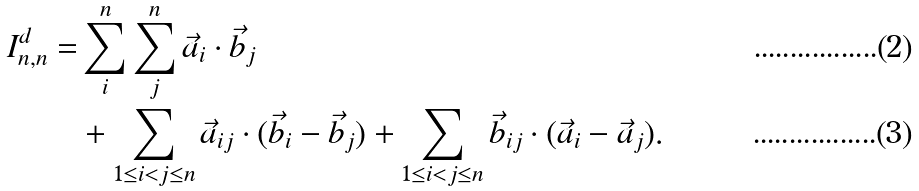Convert formula to latex. <formula><loc_0><loc_0><loc_500><loc_500>I ^ { d } _ { n , n } = & \sum _ { i } ^ { n } \sum _ { j } ^ { n } { \vec { a } _ { i } \cdot \vec { b } _ { j } } \\ & + \sum _ { 1 \leq i < j \leq n } { \vec { a } _ { i j } \cdot ( \vec { b } _ { i } - \vec { b } _ { j } ) } + \sum _ { 1 \leq i < j \leq n } { \vec { b } _ { i j } \cdot ( \vec { a } _ { i } - \vec { a } _ { j } ) } .</formula> 